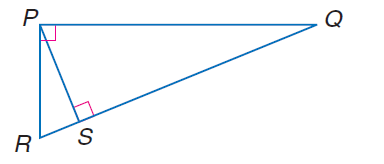Question: In \triangle P Q R, R S = 3 and Q S = 14. Find P S.
Choices:
A. \sqrt { 14 }
B. \sqrt { 42 }
C. \sqrt { 47 }
D. \sqrt { 205 }
Answer with the letter. Answer: B 